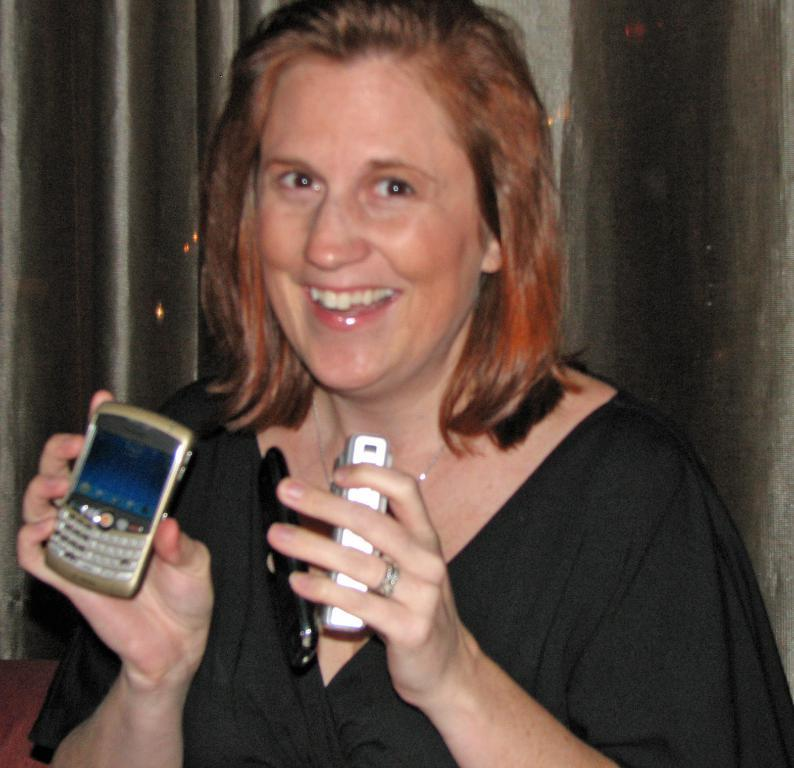Who is the main subject in the image? There is a woman in the image. What is the woman wearing? The woman is wearing a black top. Where is the woman positioned in the image? The woman is standing in the front. What expression does the woman have? The woman is smiling. What object is the woman showing in the image? The woman is showing a mobile phone. What can be seen in the background of the image? There is a black curtain in the background. What type of food is the woman eating in the image? There is no food present in the image; the woman is showing a mobile phone. What date is circled on the calendar in the image? There is no calendar present in the image. 